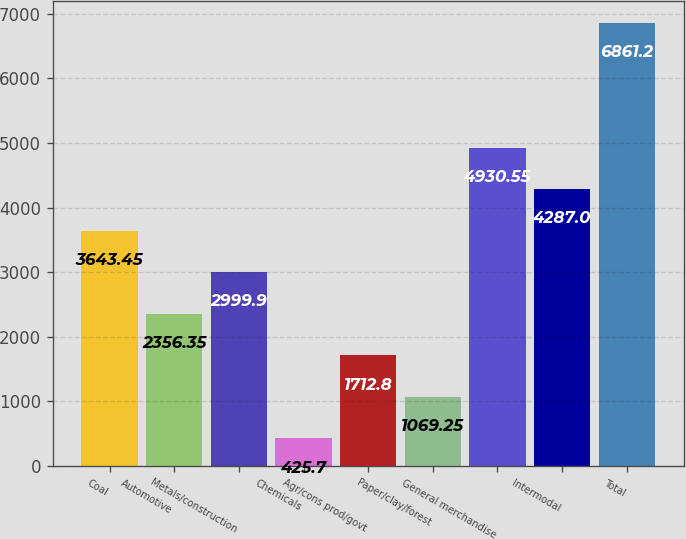<chart> <loc_0><loc_0><loc_500><loc_500><bar_chart><fcel>Coal<fcel>Automotive<fcel>Metals/construction<fcel>Chemicals<fcel>Agr/cons prod/govt<fcel>Paper/clay/forest<fcel>General merchandise<fcel>Intermodal<fcel>Total<nl><fcel>3643.45<fcel>2356.35<fcel>2999.9<fcel>425.7<fcel>1712.8<fcel>1069.25<fcel>4930.55<fcel>4287<fcel>6861.2<nl></chart> 